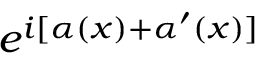Convert formula to latex. <formula><loc_0><loc_0><loc_500><loc_500>e ^ { i [ \alpha ( x ) + \alpha ^ { \prime } ( x ) ] }</formula> 